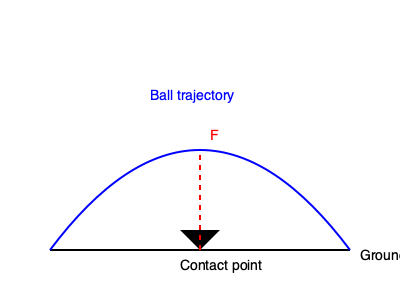In the diagram above, a soccer player's foot is about to make contact with the ball at the lowest point of the kick. If the total force applied by the foot is 500 N, what is the approximate vertical component of the force acting on the cleat, assuming the foot makes a 30° angle with the ground at the moment of impact? To solve this problem, we'll follow these steps:

1. Understand the given information:
   - Total force applied: $F = 500$ N
   - Angle between foot and ground: $\theta = 30°$

2. Recall the trigonometric relationship for finding the vertical component of a force:
   - Vertical component = Total force × sin(angle)

3. Apply the formula:
   - Vertical component = $F \times \sin(\theta)$
   - Vertical component = $500 \text{ N} \times \sin(30°)$

4. Calculate the result:
   - $\sin(30°) = 0.5$
   - Vertical component = $500 \text{ N} \times 0.5 = 250 \text{ N}$

Therefore, the vertical component of the force acting on the cleat is approximately 250 N.
Answer: 250 N 